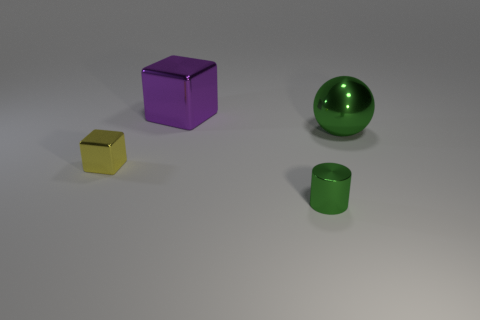Add 4 large purple metal blocks. How many objects exist? 8 Add 4 large green objects. How many large green objects exist? 5 Subtract 0 cyan cubes. How many objects are left? 4 Subtract all cylinders. How many objects are left? 3 Subtract all small red metallic blocks. Subtract all large green objects. How many objects are left? 3 Add 3 cylinders. How many cylinders are left? 4 